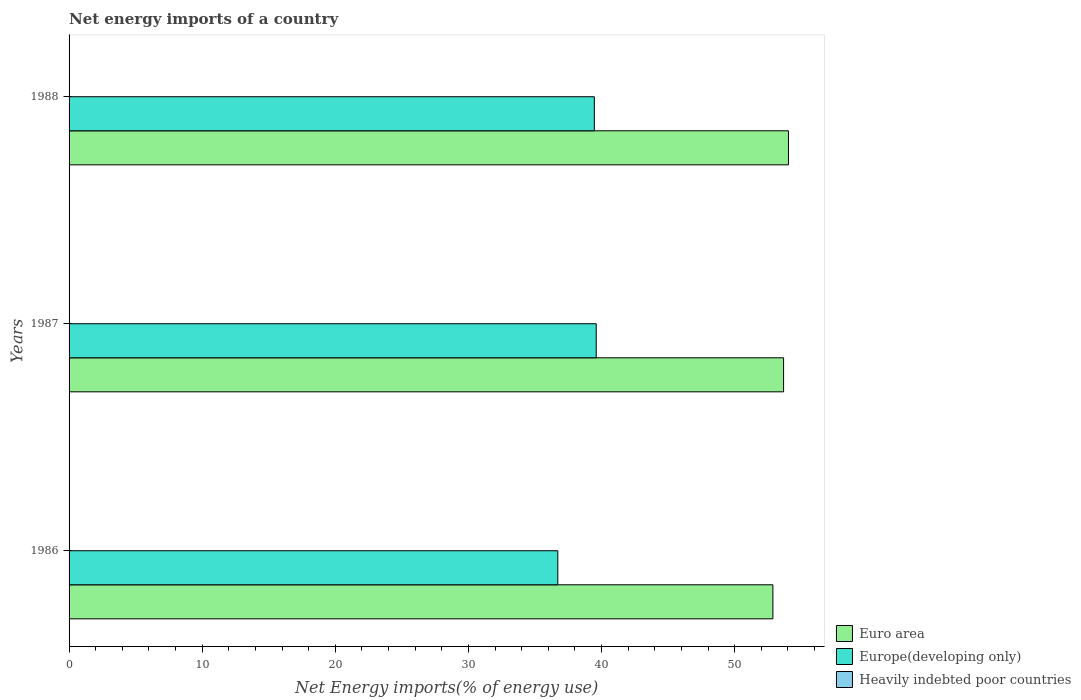How many groups of bars are there?
Give a very brief answer. 3. How many bars are there on the 1st tick from the bottom?
Give a very brief answer. 2. Across all years, what is the maximum net energy imports in Euro area?
Give a very brief answer. 54.04. Across all years, what is the minimum net energy imports in Euro area?
Your response must be concise. 52.87. In which year was the net energy imports in Europe(developing only) maximum?
Give a very brief answer. 1987. What is the total net energy imports in Euro area in the graph?
Offer a terse response. 160.58. What is the difference between the net energy imports in Euro area in 1986 and that in 1988?
Your answer should be compact. -1.17. What is the difference between the net energy imports in Heavily indebted poor countries in 1988 and the net energy imports in Europe(developing only) in 1986?
Provide a succinct answer. -36.71. What is the average net energy imports in Europe(developing only) per year?
Provide a succinct answer. 38.59. In the year 1986, what is the difference between the net energy imports in Euro area and net energy imports in Europe(developing only)?
Offer a terse response. 16.15. In how many years, is the net energy imports in Europe(developing only) greater than 42 %?
Provide a short and direct response. 0. What is the ratio of the net energy imports in Euro area in 1987 to that in 1988?
Provide a short and direct response. 0.99. Is the net energy imports in Euro area in 1987 less than that in 1988?
Your answer should be very brief. Yes. What is the difference between the highest and the second highest net energy imports in Euro area?
Your response must be concise. 0.37. What is the difference between the highest and the lowest net energy imports in Europe(developing only)?
Offer a very short reply. 2.88. Is the sum of the net energy imports in Europe(developing only) in 1986 and 1987 greater than the maximum net energy imports in Euro area across all years?
Your answer should be very brief. Yes. Are all the bars in the graph horizontal?
Your answer should be compact. Yes. How many years are there in the graph?
Your response must be concise. 3. What is the difference between two consecutive major ticks on the X-axis?
Provide a succinct answer. 10. Does the graph contain any zero values?
Give a very brief answer. Yes. Does the graph contain grids?
Give a very brief answer. No. Where does the legend appear in the graph?
Give a very brief answer. Bottom right. How many legend labels are there?
Your answer should be compact. 3. How are the legend labels stacked?
Your answer should be very brief. Vertical. What is the title of the graph?
Your answer should be very brief. Net energy imports of a country. What is the label or title of the X-axis?
Give a very brief answer. Net Energy imports(% of energy use). What is the label or title of the Y-axis?
Your answer should be compact. Years. What is the Net Energy imports(% of energy use) of Euro area in 1986?
Your response must be concise. 52.87. What is the Net Energy imports(% of energy use) in Europe(developing only) in 1986?
Offer a terse response. 36.71. What is the Net Energy imports(% of energy use) of Heavily indebted poor countries in 1986?
Make the answer very short. 0. What is the Net Energy imports(% of energy use) of Euro area in 1987?
Make the answer very short. 53.67. What is the Net Energy imports(% of energy use) in Europe(developing only) in 1987?
Offer a very short reply. 39.6. What is the Net Energy imports(% of energy use) in Heavily indebted poor countries in 1987?
Keep it short and to the point. 0. What is the Net Energy imports(% of energy use) in Euro area in 1988?
Your answer should be very brief. 54.04. What is the Net Energy imports(% of energy use) in Europe(developing only) in 1988?
Give a very brief answer. 39.46. What is the Net Energy imports(% of energy use) of Heavily indebted poor countries in 1988?
Make the answer very short. 0. Across all years, what is the maximum Net Energy imports(% of energy use) in Euro area?
Your response must be concise. 54.04. Across all years, what is the maximum Net Energy imports(% of energy use) of Europe(developing only)?
Give a very brief answer. 39.6. Across all years, what is the minimum Net Energy imports(% of energy use) in Euro area?
Provide a short and direct response. 52.87. Across all years, what is the minimum Net Energy imports(% of energy use) in Europe(developing only)?
Offer a terse response. 36.71. What is the total Net Energy imports(% of energy use) in Euro area in the graph?
Provide a short and direct response. 160.58. What is the total Net Energy imports(% of energy use) of Europe(developing only) in the graph?
Your response must be concise. 115.77. What is the difference between the Net Energy imports(% of energy use) in Euro area in 1986 and that in 1987?
Keep it short and to the point. -0.8. What is the difference between the Net Energy imports(% of energy use) of Europe(developing only) in 1986 and that in 1987?
Keep it short and to the point. -2.88. What is the difference between the Net Energy imports(% of energy use) of Euro area in 1986 and that in 1988?
Ensure brevity in your answer.  -1.17. What is the difference between the Net Energy imports(% of energy use) in Europe(developing only) in 1986 and that in 1988?
Your response must be concise. -2.74. What is the difference between the Net Energy imports(% of energy use) of Euro area in 1987 and that in 1988?
Keep it short and to the point. -0.37. What is the difference between the Net Energy imports(% of energy use) of Europe(developing only) in 1987 and that in 1988?
Ensure brevity in your answer.  0.14. What is the difference between the Net Energy imports(% of energy use) of Euro area in 1986 and the Net Energy imports(% of energy use) of Europe(developing only) in 1987?
Your answer should be compact. 13.27. What is the difference between the Net Energy imports(% of energy use) of Euro area in 1986 and the Net Energy imports(% of energy use) of Europe(developing only) in 1988?
Offer a very short reply. 13.41. What is the difference between the Net Energy imports(% of energy use) of Euro area in 1987 and the Net Energy imports(% of energy use) of Europe(developing only) in 1988?
Offer a terse response. 14.22. What is the average Net Energy imports(% of energy use) of Euro area per year?
Your answer should be very brief. 53.53. What is the average Net Energy imports(% of energy use) in Europe(developing only) per year?
Your response must be concise. 38.59. What is the average Net Energy imports(% of energy use) of Heavily indebted poor countries per year?
Give a very brief answer. 0. In the year 1986, what is the difference between the Net Energy imports(% of energy use) of Euro area and Net Energy imports(% of energy use) of Europe(developing only)?
Give a very brief answer. 16.15. In the year 1987, what is the difference between the Net Energy imports(% of energy use) of Euro area and Net Energy imports(% of energy use) of Europe(developing only)?
Your answer should be very brief. 14.07. In the year 1988, what is the difference between the Net Energy imports(% of energy use) in Euro area and Net Energy imports(% of energy use) in Europe(developing only)?
Ensure brevity in your answer.  14.58. What is the ratio of the Net Energy imports(% of energy use) of Europe(developing only) in 1986 to that in 1987?
Make the answer very short. 0.93. What is the ratio of the Net Energy imports(% of energy use) in Euro area in 1986 to that in 1988?
Ensure brevity in your answer.  0.98. What is the ratio of the Net Energy imports(% of energy use) in Europe(developing only) in 1986 to that in 1988?
Offer a terse response. 0.93. What is the ratio of the Net Energy imports(% of energy use) of Europe(developing only) in 1987 to that in 1988?
Ensure brevity in your answer.  1. What is the difference between the highest and the second highest Net Energy imports(% of energy use) of Euro area?
Keep it short and to the point. 0.37. What is the difference between the highest and the second highest Net Energy imports(% of energy use) in Europe(developing only)?
Give a very brief answer. 0.14. What is the difference between the highest and the lowest Net Energy imports(% of energy use) in Euro area?
Ensure brevity in your answer.  1.17. What is the difference between the highest and the lowest Net Energy imports(% of energy use) in Europe(developing only)?
Keep it short and to the point. 2.88. 